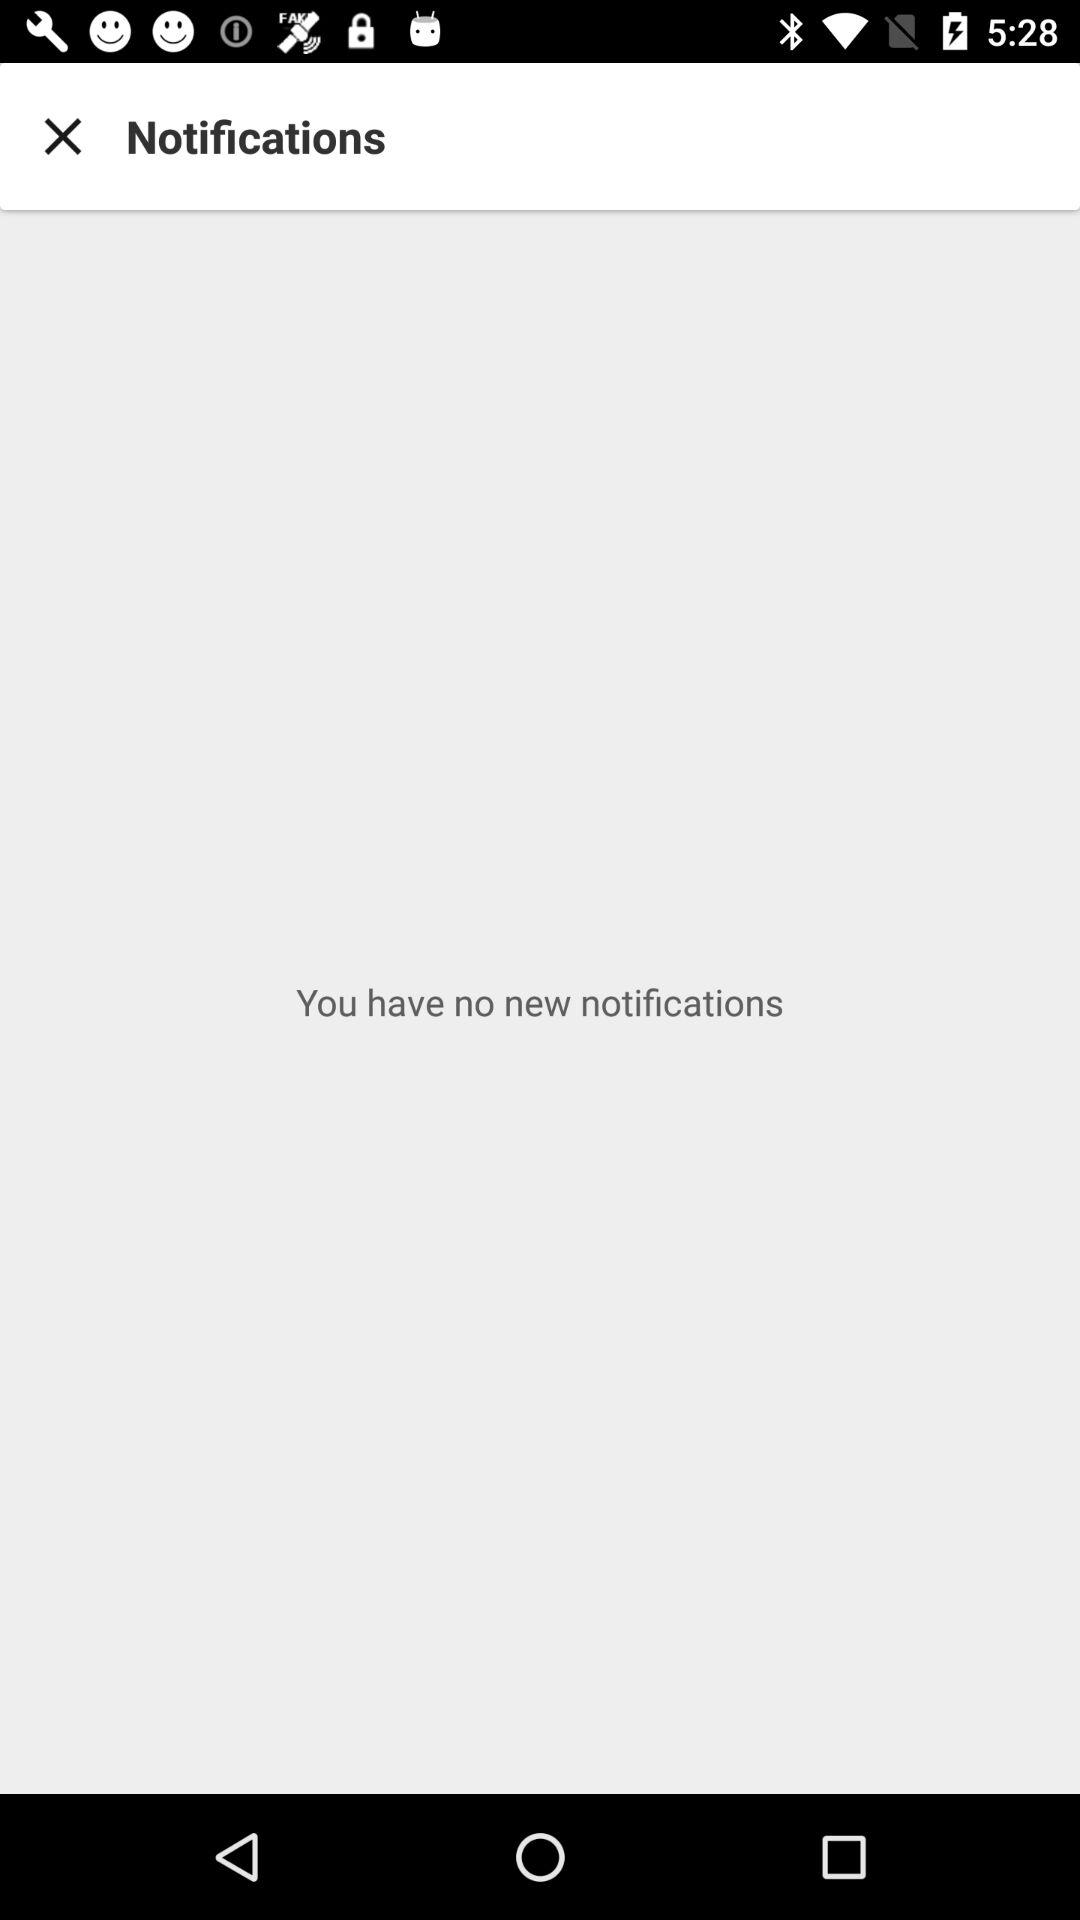How many notifications do I have?
Answer the question using a single word or phrase. 0 